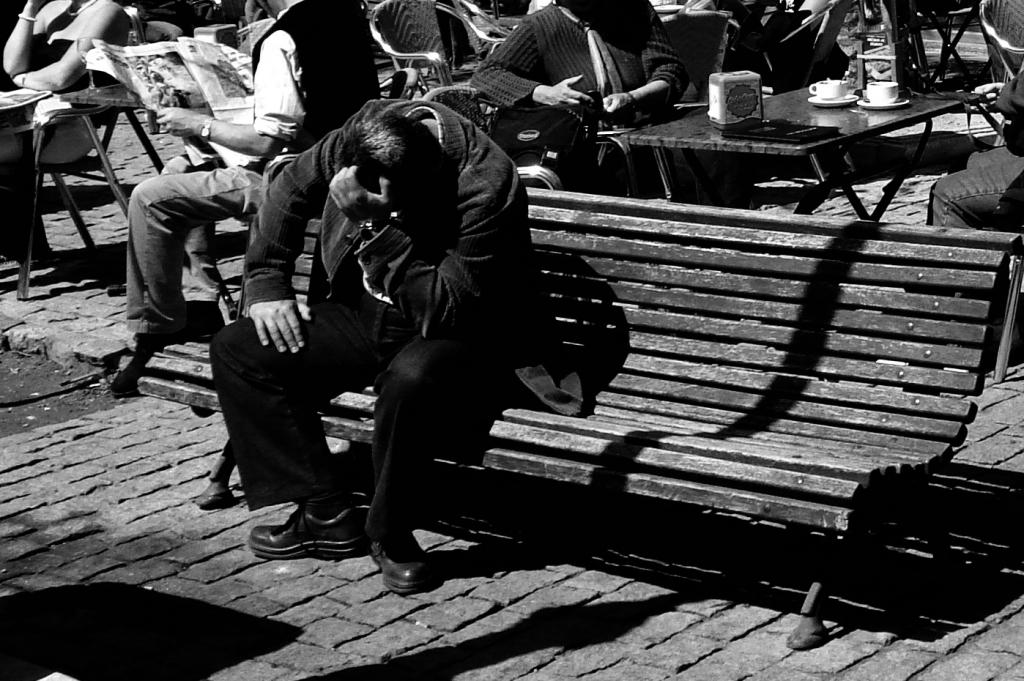What is the person in the image doing? The person is sitting on a bench in the image. Are there any other people in the image? Yes, there are other people sitting on chairs in the image. What are the chairs arranged around? The chairs are around tables in the image. What can be found on the tables? There are things on the tables in the image. Where is the wall located in the image? There is no wall present in the image. What type of tent can be seen in the image? There is no tent present in the image. 